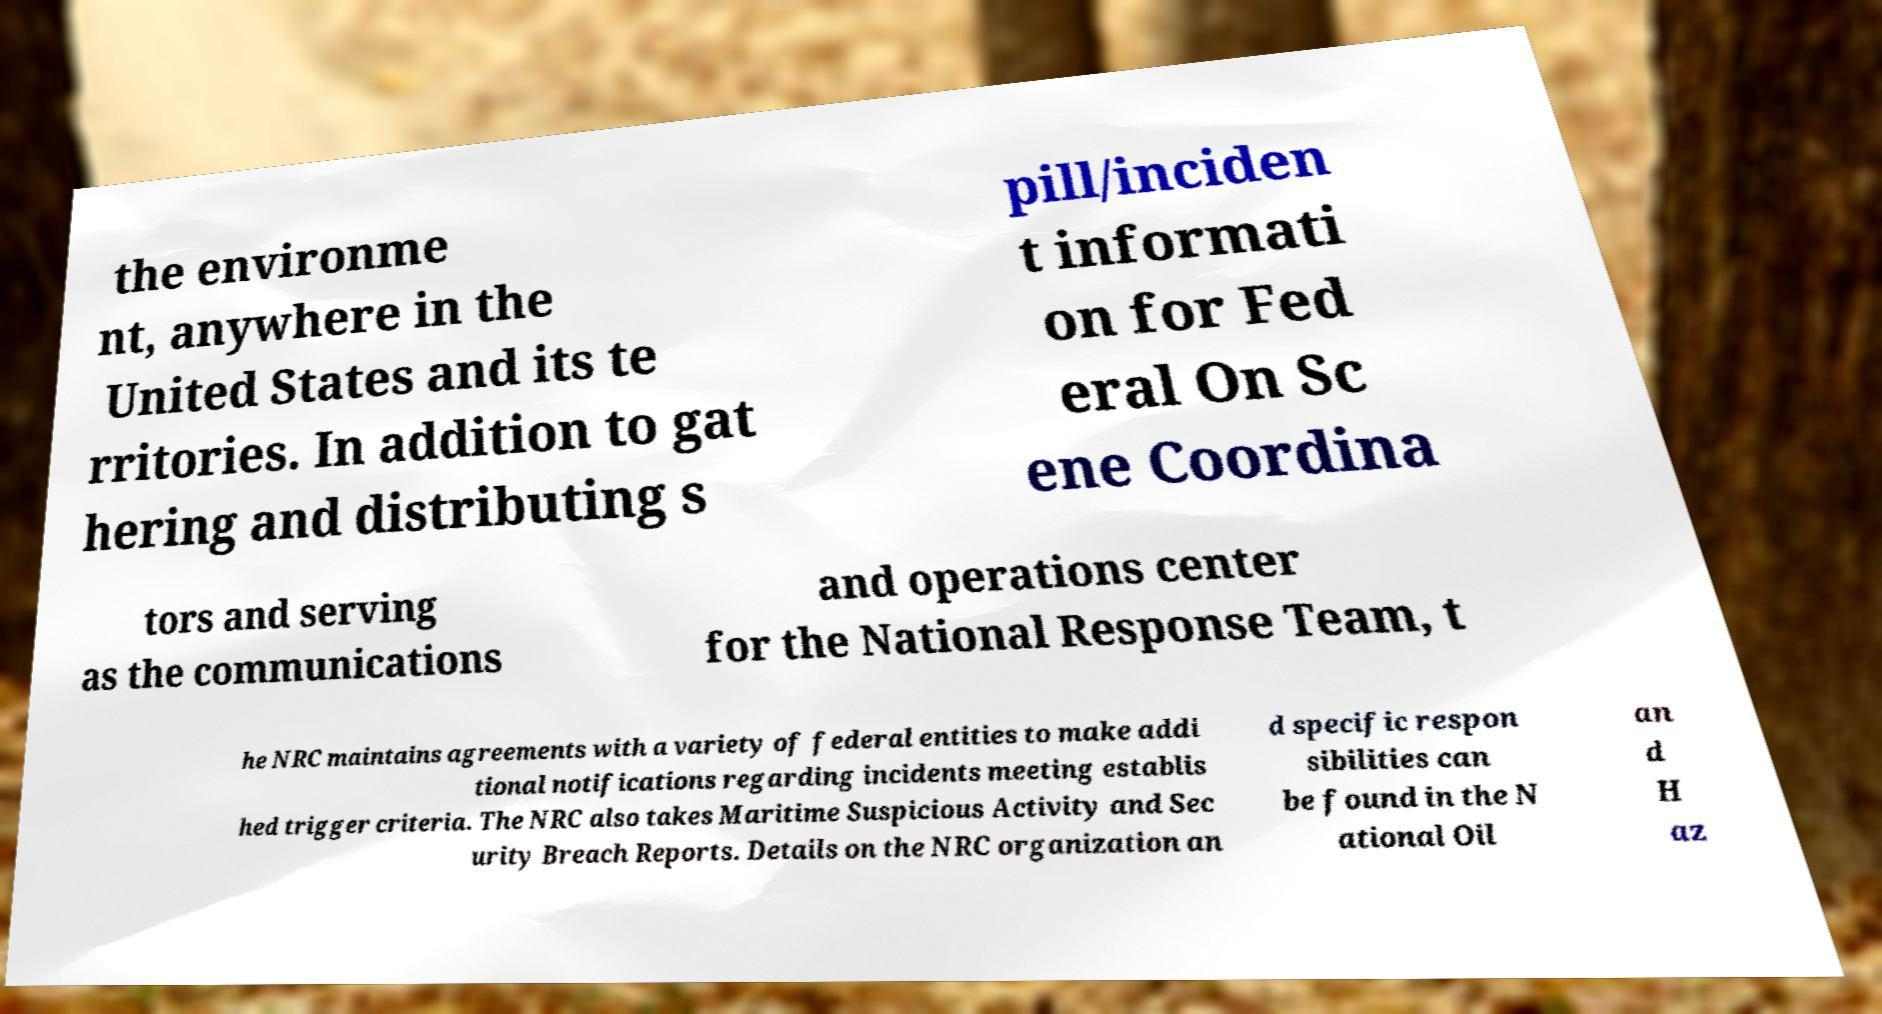I need the written content from this picture converted into text. Can you do that? the environme nt, anywhere in the United States and its te rritories. In addition to gat hering and distributing s pill/inciden t informati on for Fed eral On Sc ene Coordina tors and serving as the communications and operations center for the National Response Team, t he NRC maintains agreements with a variety of federal entities to make addi tional notifications regarding incidents meeting establis hed trigger criteria. The NRC also takes Maritime Suspicious Activity and Sec urity Breach Reports. Details on the NRC organization an d specific respon sibilities can be found in the N ational Oil an d H az 